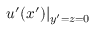Convert formula to latex. <formula><loc_0><loc_0><loc_500><loc_500>u ^ { \prime } ( x ^ { \prime } ) | _ { y ^ { \prime } = z = 0 }</formula> 